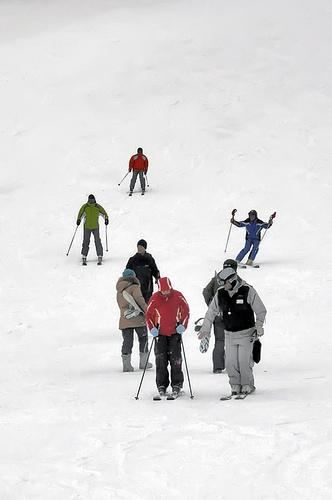What is the man in grey pants doing? skiing 